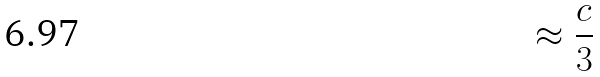<formula> <loc_0><loc_0><loc_500><loc_500>\approx \frac { c } { 3 }</formula> 